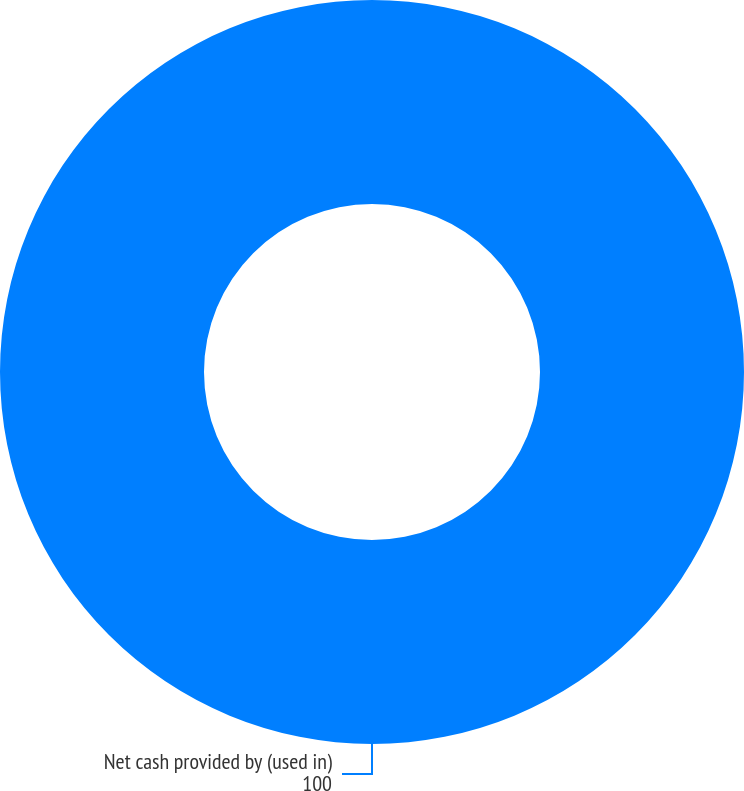Convert chart to OTSL. <chart><loc_0><loc_0><loc_500><loc_500><pie_chart><fcel>Net cash provided by (used in)<nl><fcel>100.0%<nl></chart> 